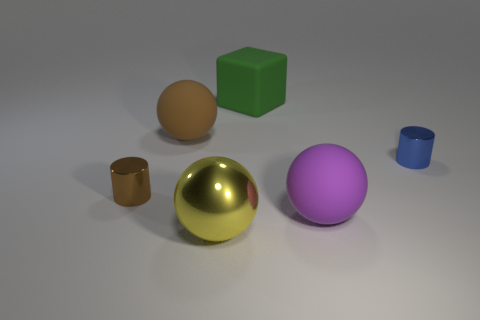Are there more large green rubber things than things?
Offer a very short reply. No. There is a large matte thing that is behind the brown rubber thing on the right side of the brown object that is in front of the brown rubber object; what shape is it?
Provide a succinct answer. Cube. Are the big cube right of the big brown thing and the big object that is on the right side of the large green rubber block made of the same material?
Offer a very short reply. Yes. What is the shape of the small blue object that is the same material as the small brown thing?
Your response must be concise. Cylinder. Is there anything else that is the same color as the big metal sphere?
Offer a very short reply. No. How many purple things are there?
Provide a short and direct response. 1. There is a object that is behind the big object that is on the left side of the big yellow metallic sphere; what is its material?
Your response must be concise. Rubber. What is the color of the large rubber ball on the right side of the large yellow sphere that is to the right of the sphere behind the blue object?
Provide a succinct answer. Purple. How many brown objects have the same size as the yellow object?
Offer a very short reply. 1. Are there more rubber objects left of the big metal sphere than big shiny balls on the right side of the block?
Provide a succinct answer. Yes. 